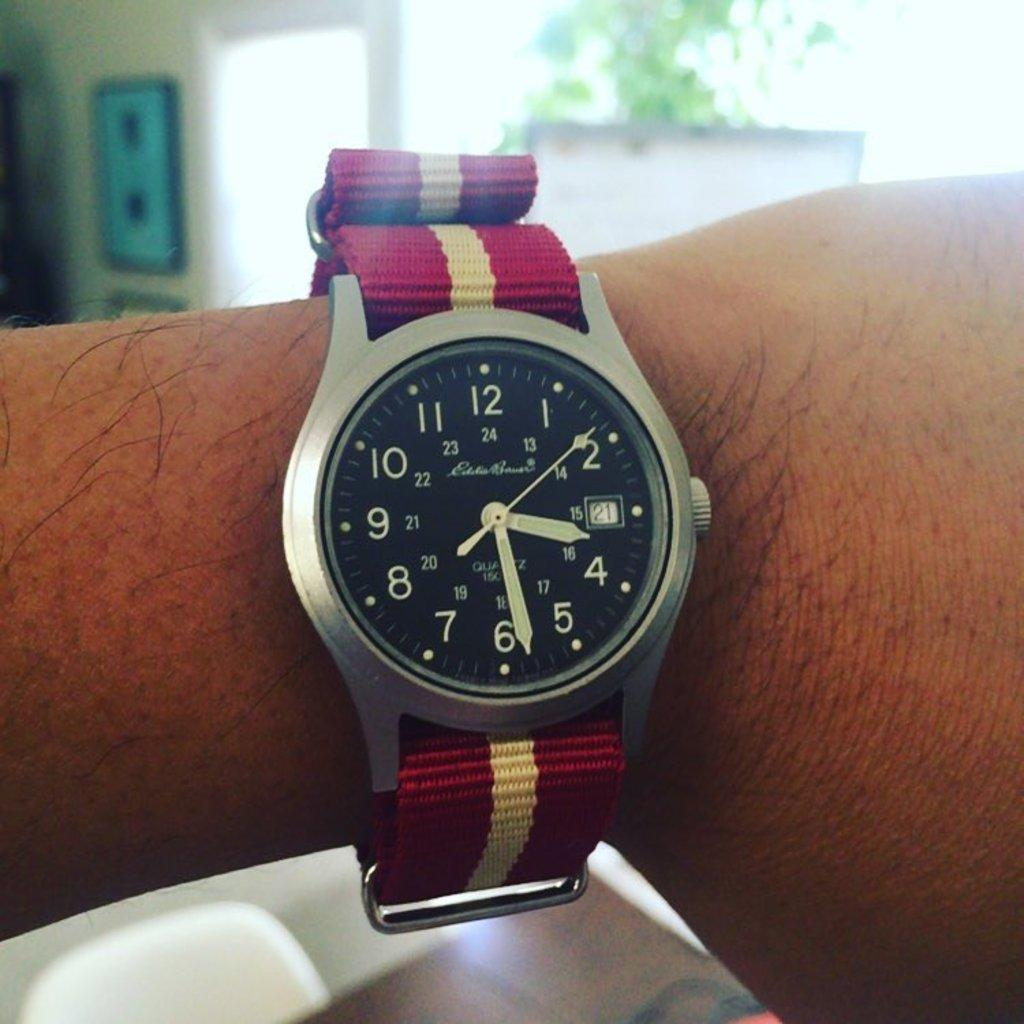<image>
Give a short and clear explanation of the subsequent image. A person is wearing an Eddie Bauer watch on their wrist. 